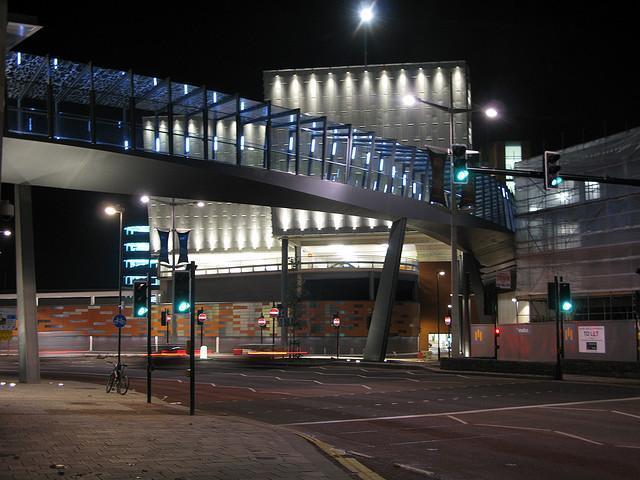How many people are wearing hats?
Give a very brief answer. 0. 